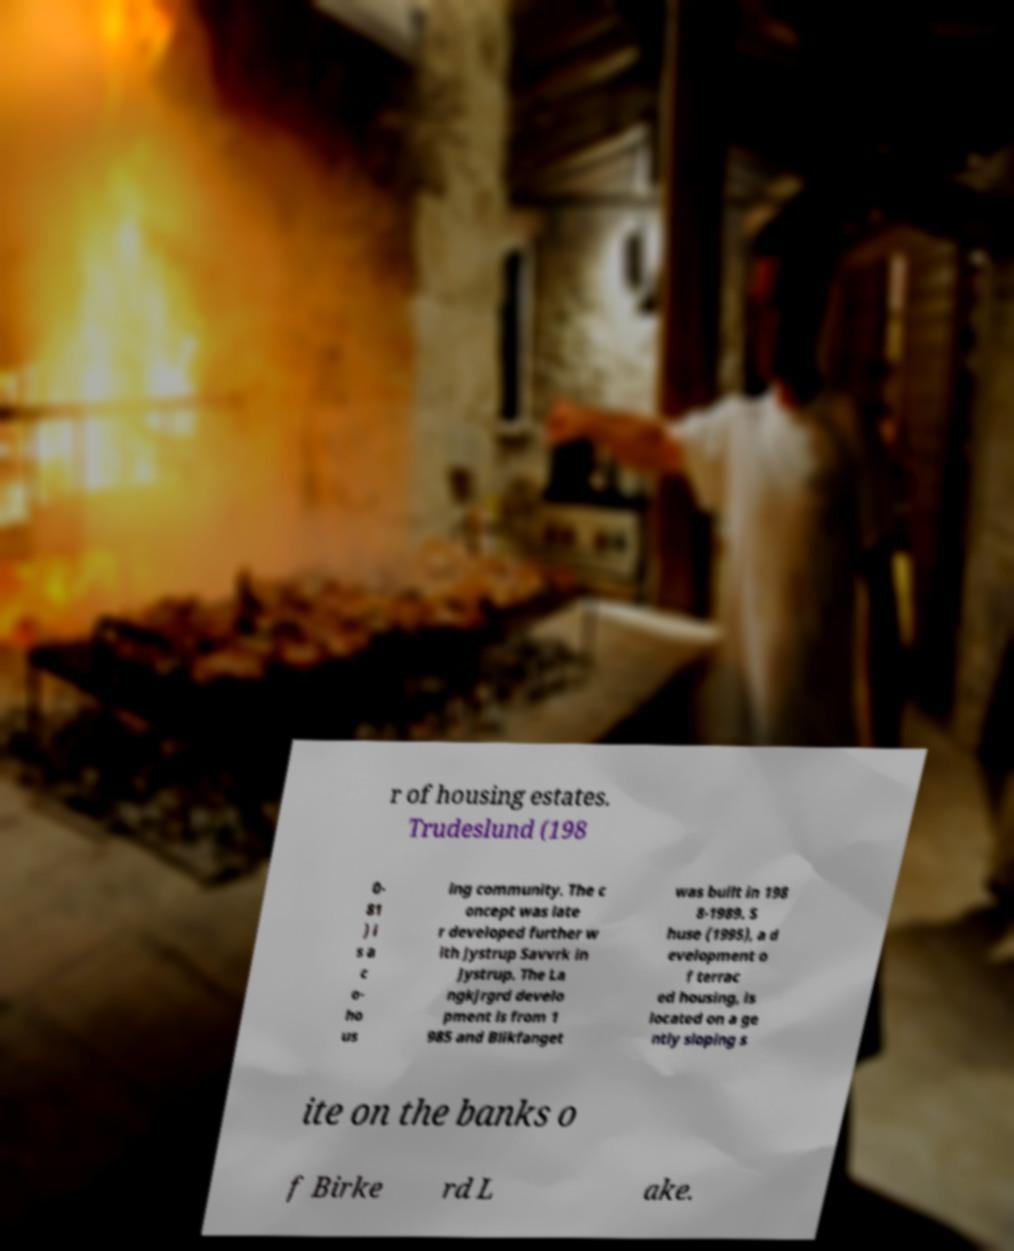There's text embedded in this image that I need extracted. Can you transcribe it verbatim? r of housing estates. Trudeslund (198 0- 81 ) i s a c o- ho us ing community. The c oncept was late r developed further w ith Jystrup Savvrk in Jystrup. The La ngkjrgrd develo pment is from 1 985 and Blikfanget was built in 198 8-1989. S huse (1995), a d evelopment o f terrac ed housing, is located on a ge ntly sloping s ite on the banks o f Birke rd L ake. 